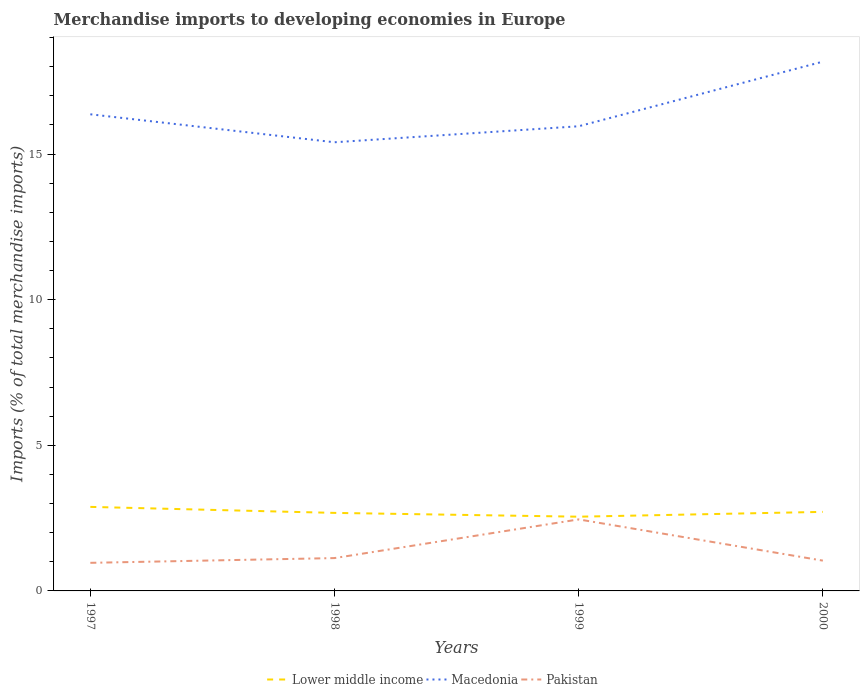Is the number of lines equal to the number of legend labels?
Ensure brevity in your answer.  Yes. Across all years, what is the maximum percentage total merchandise imports in Pakistan?
Give a very brief answer. 0.96. What is the total percentage total merchandise imports in Lower middle income in the graph?
Your answer should be compact. 0.34. What is the difference between the highest and the second highest percentage total merchandise imports in Macedonia?
Your answer should be compact. 2.77. Is the percentage total merchandise imports in Pakistan strictly greater than the percentage total merchandise imports in Lower middle income over the years?
Your answer should be compact. Yes. How many years are there in the graph?
Offer a terse response. 4. Are the values on the major ticks of Y-axis written in scientific E-notation?
Offer a terse response. No. Does the graph contain grids?
Offer a terse response. No. How many legend labels are there?
Offer a very short reply. 3. How are the legend labels stacked?
Keep it short and to the point. Horizontal. What is the title of the graph?
Make the answer very short. Merchandise imports to developing economies in Europe. What is the label or title of the X-axis?
Offer a very short reply. Years. What is the label or title of the Y-axis?
Ensure brevity in your answer.  Imports (% of total merchandise imports). What is the Imports (% of total merchandise imports) of Lower middle income in 1997?
Your answer should be very brief. 2.89. What is the Imports (% of total merchandise imports) in Macedonia in 1997?
Offer a terse response. 16.36. What is the Imports (% of total merchandise imports) in Pakistan in 1997?
Provide a short and direct response. 0.96. What is the Imports (% of total merchandise imports) of Lower middle income in 1998?
Provide a succinct answer. 2.68. What is the Imports (% of total merchandise imports) of Macedonia in 1998?
Your answer should be compact. 15.4. What is the Imports (% of total merchandise imports) in Pakistan in 1998?
Your response must be concise. 1.13. What is the Imports (% of total merchandise imports) in Lower middle income in 1999?
Offer a very short reply. 2.55. What is the Imports (% of total merchandise imports) in Macedonia in 1999?
Make the answer very short. 15.95. What is the Imports (% of total merchandise imports) in Pakistan in 1999?
Provide a short and direct response. 2.46. What is the Imports (% of total merchandise imports) of Lower middle income in 2000?
Make the answer very short. 2.71. What is the Imports (% of total merchandise imports) of Macedonia in 2000?
Keep it short and to the point. 18.17. What is the Imports (% of total merchandise imports) of Pakistan in 2000?
Ensure brevity in your answer.  1.04. Across all years, what is the maximum Imports (% of total merchandise imports) in Lower middle income?
Offer a terse response. 2.89. Across all years, what is the maximum Imports (% of total merchandise imports) of Macedonia?
Make the answer very short. 18.17. Across all years, what is the maximum Imports (% of total merchandise imports) of Pakistan?
Keep it short and to the point. 2.46. Across all years, what is the minimum Imports (% of total merchandise imports) in Lower middle income?
Your answer should be compact. 2.55. Across all years, what is the minimum Imports (% of total merchandise imports) of Macedonia?
Give a very brief answer. 15.4. Across all years, what is the minimum Imports (% of total merchandise imports) in Pakistan?
Offer a terse response. 0.96. What is the total Imports (% of total merchandise imports) in Lower middle income in the graph?
Your response must be concise. 10.83. What is the total Imports (% of total merchandise imports) in Macedonia in the graph?
Your answer should be compact. 65.89. What is the total Imports (% of total merchandise imports) of Pakistan in the graph?
Offer a very short reply. 5.59. What is the difference between the Imports (% of total merchandise imports) in Lower middle income in 1997 and that in 1998?
Offer a terse response. 0.21. What is the difference between the Imports (% of total merchandise imports) of Macedonia in 1997 and that in 1998?
Make the answer very short. 0.96. What is the difference between the Imports (% of total merchandise imports) in Pakistan in 1997 and that in 1998?
Your answer should be compact. -0.16. What is the difference between the Imports (% of total merchandise imports) of Lower middle income in 1997 and that in 1999?
Your response must be concise. 0.34. What is the difference between the Imports (% of total merchandise imports) in Macedonia in 1997 and that in 1999?
Provide a short and direct response. 0.41. What is the difference between the Imports (% of total merchandise imports) of Pakistan in 1997 and that in 1999?
Your answer should be very brief. -1.49. What is the difference between the Imports (% of total merchandise imports) of Lower middle income in 1997 and that in 2000?
Provide a short and direct response. 0.17. What is the difference between the Imports (% of total merchandise imports) in Macedonia in 1997 and that in 2000?
Ensure brevity in your answer.  -1.81. What is the difference between the Imports (% of total merchandise imports) of Pakistan in 1997 and that in 2000?
Your answer should be compact. -0.08. What is the difference between the Imports (% of total merchandise imports) of Lower middle income in 1998 and that in 1999?
Keep it short and to the point. 0.13. What is the difference between the Imports (% of total merchandise imports) in Macedonia in 1998 and that in 1999?
Ensure brevity in your answer.  -0.55. What is the difference between the Imports (% of total merchandise imports) of Pakistan in 1998 and that in 1999?
Provide a short and direct response. -1.33. What is the difference between the Imports (% of total merchandise imports) in Lower middle income in 1998 and that in 2000?
Provide a succinct answer. -0.04. What is the difference between the Imports (% of total merchandise imports) in Macedonia in 1998 and that in 2000?
Provide a short and direct response. -2.77. What is the difference between the Imports (% of total merchandise imports) of Pakistan in 1998 and that in 2000?
Keep it short and to the point. 0.09. What is the difference between the Imports (% of total merchandise imports) in Lower middle income in 1999 and that in 2000?
Provide a succinct answer. -0.17. What is the difference between the Imports (% of total merchandise imports) in Macedonia in 1999 and that in 2000?
Your response must be concise. -2.22. What is the difference between the Imports (% of total merchandise imports) in Pakistan in 1999 and that in 2000?
Offer a terse response. 1.42. What is the difference between the Imports (% of total merchandise imports) in Lower middle income in 1997 and the Imports (% of total merchandise imports) in Macedonia in 1998?
Your answer should be very brief. -12.52. What is the difference between the Imports (% of total merchandise imports) of Lower middle income in 1997 and the Imports (% of total merchandise imports) of Pakistan in 1998?
Your answer should be compact. 1.76. What is the difference between the Imports (% of total merchandise imports) in Macedonia in 1997 and the Imports (% of total merchandise imports) in Pakistan in 1998?
Give a very brief answer. 15.24. What is the difference between the Imports (% of total merchandise imports) of Lower middle income in 1997 and the Imports (% of total merchandise imports) of Macedonia in 1999?
Your answer should be compact. -13.07. What is the difference between the Imports (% of total merchandise imports) in Lower middle income in 1997 and the Imports (% of total merchandise imports) in Pakistan in 1999?
Ensure brevity in your answer.  0.43. What is the difference between the Imports (% of total merchandise imports) of Macedonia in 1997 and the Imports (% of total merchandise imports) of Pakistan in 1999?
Ensure brevity in your answer.  13.91. What is the difference between the Imports (% of total merchandise imports) of Lower middle income in 1997 and the Imports (% of total merchandise imports) of Macedonia in 2000?
Offer a terse response. -15.29. What is the difference between the Imports (% of total merchandise imports) of Lower middle income in 1997 and the Imports (% of total merchandise imports) of Pakistan in 2000?
Provide a succinct answer. 1.84. What is the difference between the Imports (% of total merchandise imports) of Macedonia in 1997 and the Imports (% of total merchandise imports) of Pakistan in 2000?
Ensure brevity in your answer.  15.32. What is the difference between the Imports (% of total merchandise imports) of Lower middle income in 1998 and the Imports (% of total merchandise imports) of Macedonia in 1999?
Your answer should be compact. -13.27. What is the difference between the Imports (% of total merchandise imports) of Lower middle income in 1998 and the Imports (% of total merchandise imports) of Pakistan in 1999?
Give a very brief answer. 0.22. What is the difference between the Imports (% of total merchandise imports) of Macedonia in 1998 and the Imports (% of total merchandise imports) of Pakistan in 1999?
Provide a succinct answer. 12.95. What is the difference between the Imports (% of total merchandise imports) in Lower middle income in 1998 and the Imports (% of total merchandise imports) in Macedonia in 2000?
Your answer should be very brief. -15.49. What is the difference between the Imports (% of total merchandise imports) of Lower middle income in 1998 and the Imports (% of total merchandise imports) of Pakistan in 2000?
Your answer should be very brief. 1.64. What is the difference between the Imports (% of total merchandise imports) of Macedonia in 1998 and the Imports (% of total merchandise imports) of Pakistan in 2000?
Offer a terse response. 14.36. What is the difference between the Imports (% of total merchandise imports) of Lower middle income in 1999 and the Imports (% of total merchandise imports) of Macedonia in 2000?
Your answer should be compact. -15.62. What is the difference between the Imports (% of total merchandise imports) of Lower middle income in 1999 and the Imports (% of total merchandise imports) of Pakistan in 2000?
Provide a succinct answer. 1.51. What is the difference between the Imports (% of total merchandise imports) in Macedonia in 1999 and the Imports (% of total merchandise imports) in Pakistan in 2000?
Your answer should be very brief. 14.91. What is the average Imports (% of total merchandise imports) in Lower middle income per year?
Offer a terse response. 2.71. What is the average Imports (% of total merchandise imports) in Macedonia per year?
Keep it short and to the point. 16.47. What is the average Imports (% of total merchandise imports) in Pakistan per year?
Your answer should be compact. 1.4. In the year 1997, what is the difference between the Imports (% of total merchandise imports) of Lower middle income and Imports (% of total merchandise imports) of Macedonia?
Keep it short and to the point. -13.48. In the year 1997, what is the difference between the Imports (% of total merchandise imports) in Lower middle income and Imports (% of total merchandise imports) in Pakistan?
Offer a terse response. 1.92. In the year 1997, what is the difference between the Imports (% of total merchandise imports) in Macedonia and Imports (% of total merchandise imports) in Pakistan?
Provide a succinct answer. 15.4. In the year 1998, what is the difference between the Imports (% of total merchandise imports) in Lower middle income and Imports (% of total merchandise imports) in Macedonia?
Keep it short and to the point. -12.72. In the year 1998, what is the difference between the Imports (% of total merchandise imports) of Lower middle income and Imports (% of total merchandise imports) of Pakistan?
Offer a terse response. 1.55. In the year 1998, what is the difference between the Imports (% of total merchandise imports) in Macedonia and Imports (% of total merchandise imports) in Pakistan?
Offer a terse response. 14.28. In the year 1999, what is the difference between the Imports (% of total merchandise imports) of Lower middle income and Imports (% of total merchandise imports) of Macedonia?
Keep it short and to the point. -13.4. In the year 1999, what is the difference between the Imports (% of total merchandise imports) of Lower middle income and Imports (% of total merchandise imports) of Pakistan?
Your answer should be very brief. 0.09. In the year 1999, what is the difference between the Imports (% of total merchandise imports) in Macedonia and Imports (% of total merchandise imports) in Pakistan?
Your response must be concise. 13.5. In the year 2000, what is the difference between the Imports (% of total merchandise imports) in Lower middle income and Imports (% of total merchandise imports) in Macedonia?
Give a very brief answer. -15.46. In the year 2000, what is the difference between the Imports (% of total merchandise imports) of Lower middle income and Imports (% of total merchandise imports) of Pakistan?
Offer a terse response. 1.67. In the year 2000, what is the difference between the Imports (% of total merchandise imports) in Macedonia and Imports (% of total merchandise imports) in Pakistan?
Your response must be concise. 17.13. What is the ratio of the Imports (% of total merchandise imports) in Lower middle income in 1997 to that in 1998?
Your answer should be very brief. 1.08. What is the ratio of the Imports (% of total merchandise imports) in Macedonia in 1997 to that in 1998?
Provide a short and direct response. 1.06. What is the ratio of the Imports (% of total merchandise imports) of Pakistan in 1997 to that in 1998?
Give a very brief answer. 0.86. What is the ratio of the Imports (% of total merchandise imports) of Lower middle income in 1997 to that in 1999?
Provide a short and direct response. 1.13. What is the ratio of the Imports (% of total merchandise imports) in Macedonia in 1997 to that in 1999?
Provide a short and direct response. 1.03. What is the ratio of the Imports (% of total merchandise imports) in Pakistan in 1997 to that in 1999?
Offer a terse response. 0.39. What is the ratio of the Imports (% of total merchandise imports) of Lower middle income in 1997 to that in 2000?
Offer a terse response. 1.06. What is the ratio of the Imports (% of total merchandise imports) of Macedonia in 1997 to that in 2000?
Keep it short and to the point. 0.9. What is the ratio of the Imports (% of total merchandise imports) of Pakistan in 1997 to that in 2000?
Make the answer very short. 0.93. What is the ratio of the Imports (% of total merchandise imports) of Lower middle income in 1998 to that in 1999?
Provide a succinct answer. 1.05. What is the ratio of the Imports (% of total merchandise imports) of Macedonia in 1998 to that in 1999?
Offer a terse response. 0.97. What is the ratio of the Imports (% of total merchandise imports) in Pakistan in 1998 to that in 1999?
Your answer should be very brief. 0.46. What is the ratio of the Imports (% of total merchandise imports) of Macedonia in 1998 to that in 2000?
Offer a terse response. 0.85. What is the ratio of the Imports (% of total merchandise imports) of Pakistan in 1998 to that in 2000?
Offer a terse response. 1.08. What is the ratio of the Imports (% of total merchandise imports) in Lower middle income in 1999 to that in 2000?
Your answer should be compact. 0.94. What is the ratio of the Imports (% of total merchandise imports) of Macedonia in 1999 to that in 2000?
Your answer should be compact. 0.88. What is the ratio of the Imports (% of total merchandise imports) in Pakistan in 1999 to that in 2000?
Your answer should be very brief. 2.36. What is the difference between the highest and the second highest Imports (% of total merchandise imports) of Lower middle income?
Make the answer very short. 0.17. What is the difference between the highest and the second highest Imports (% of total merchandise imports) in Macedonia?
Give a very brief answer. 1.81. What is the difference between the highest and the second highest Imports (% of total merchandise imports) of Pakistan?
Offer a very short reply. 1.33. What is the difference between the highest and the lowest Imports (% of total merchandise imports) in Lower middle income?
Ensure brevity in your answer.  0.34. What is the difference between the highest and the lowest Imports (% of total merchandise imports) of Macedonia?
Provide a succinct answer. 2.77. What is the difference between the highest and the lowest Imports (% of total merchandise imports) in Pakistan?
Keep it short and to the point. 1.49. 